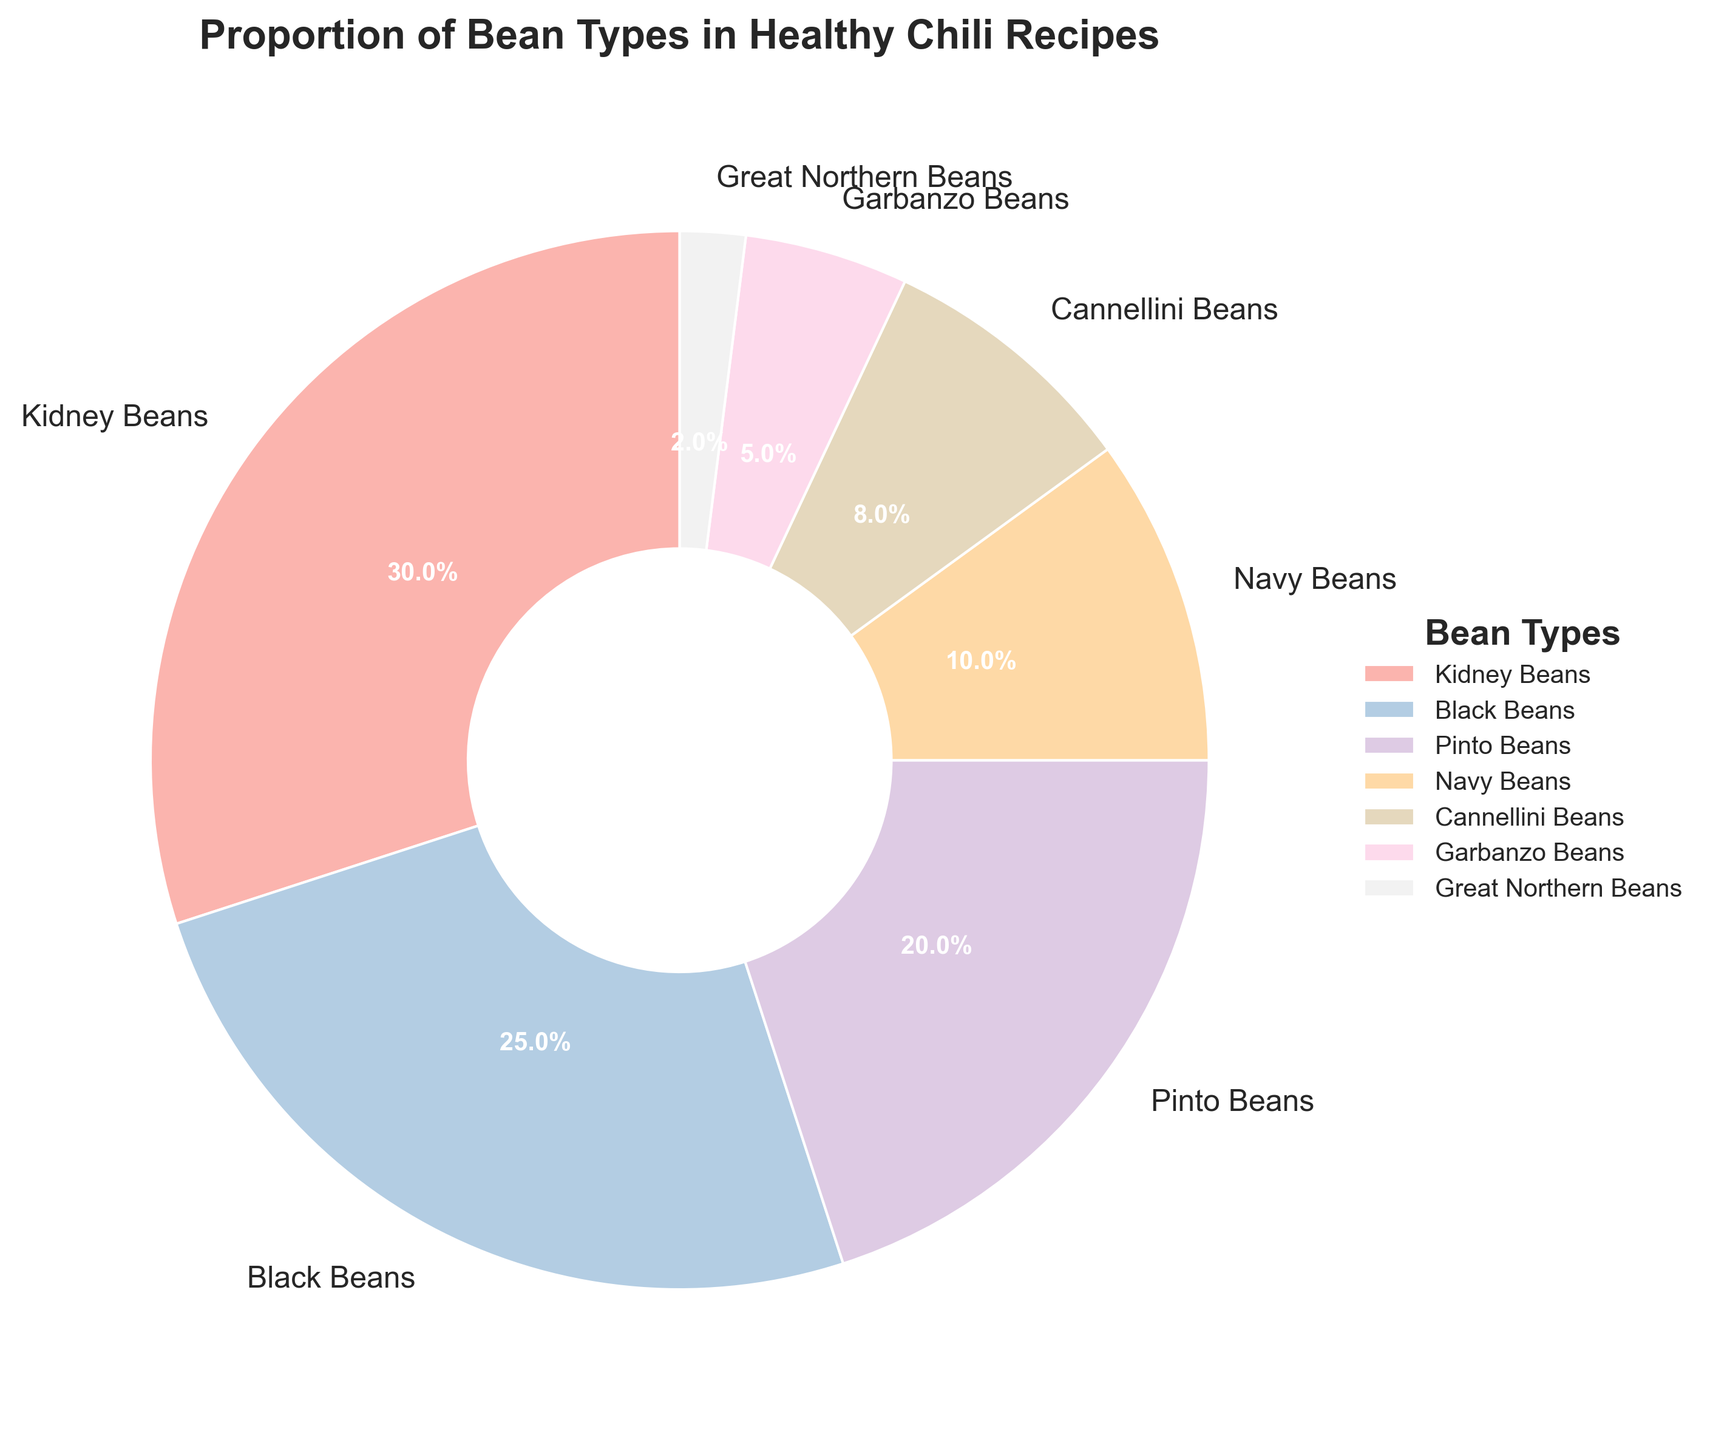Which type of bean is used the most in healthy chili recipes? The pie chart shows the proportion of different types of beans used. By looking at the largest wedge, Kidney Beans make up 30%, which is the highest percentage.
Answer: Kidney Beans Which two types of beans together make up 45% of the recipe? According to the pie chart, Kidney Beans and Black Beans are 30% and 25%, respectively. Together they sum up to 55%. However, Kidney Beans at 30% and Pinto Beans at 20% sum up to 50%, so they are ruled out. Black Beans at 25% and Pinto Beans at 20% sum to 45%.
Answer: Black Beans and Pinto Beans Are Garbanzo Beans proportionately more or less than Navy Beans? The pie chart shows Garbanzo Beans at 5% and Navy Beans at 10%. Thus, Garbanzo Beans are proportionately less than Navy Beans.
Answer: Less What is the total percentage covered by Cannellini Beans and Great Northern Beans combined? The pie chart indicates that Cannellini Beans have 8% and Great Northern Beans have 2%. Adding these percentages together, 8% + 2% equals 10%.
Answer: 10% How much more percentage do Black Beans have compared to Garbanzo Beans? The pie chart shows Black Beans at 25% and Garbanzo Beans at 5%. Subtracting Garbanzo Beans' percentage from Black Beans' percentage, 25% - 5% equals 20%.
Answer: 20% Rank the bean types from highest to lowest percentage used in the recipe. Referring to the wedges from largest to smallest: Kidney Beans (30%), Black Beans (25%), Pinto Beans (20%), Navy Beans (10%), Cannellini Beans (8%), Garbanzo Beans (5%), and Great Northern Beans (2%).
Answer: Kidney Beans, Black Beans, Pinto Beans, Navy Beans, Cannellini Beans, Garbanzo Beans, Great Northern Beans What is the average percentage of the top three bean types combined? Kidney Beans, Black Beans, Pinto Beans are the top three beans with percentages of 30%, 25%, and 20%, respectively. Their total percentage is 30 + 25 + 20 = 75%. Therefore, the average is 75 / 3 = 25%.
Answer: 25% Which bean type is third in terms of proportion used, and what percentage do they contribute? By visual inspection, the third largest segment corresponds to Pinto Beans, contributing 20% to the recipe.
Answer: Pinto Beans, 20% What is the difference in percentage between the bean type with the median percentage and the least used bean type? Sorting the percentages (30, 25, 20, 10, 8, 5, 2), the median value is 10% (Navy Beans). The least used bean type is Great Northern Beans at 2%. The difference is 10% - 2% = 8%.
Answer: 8% 